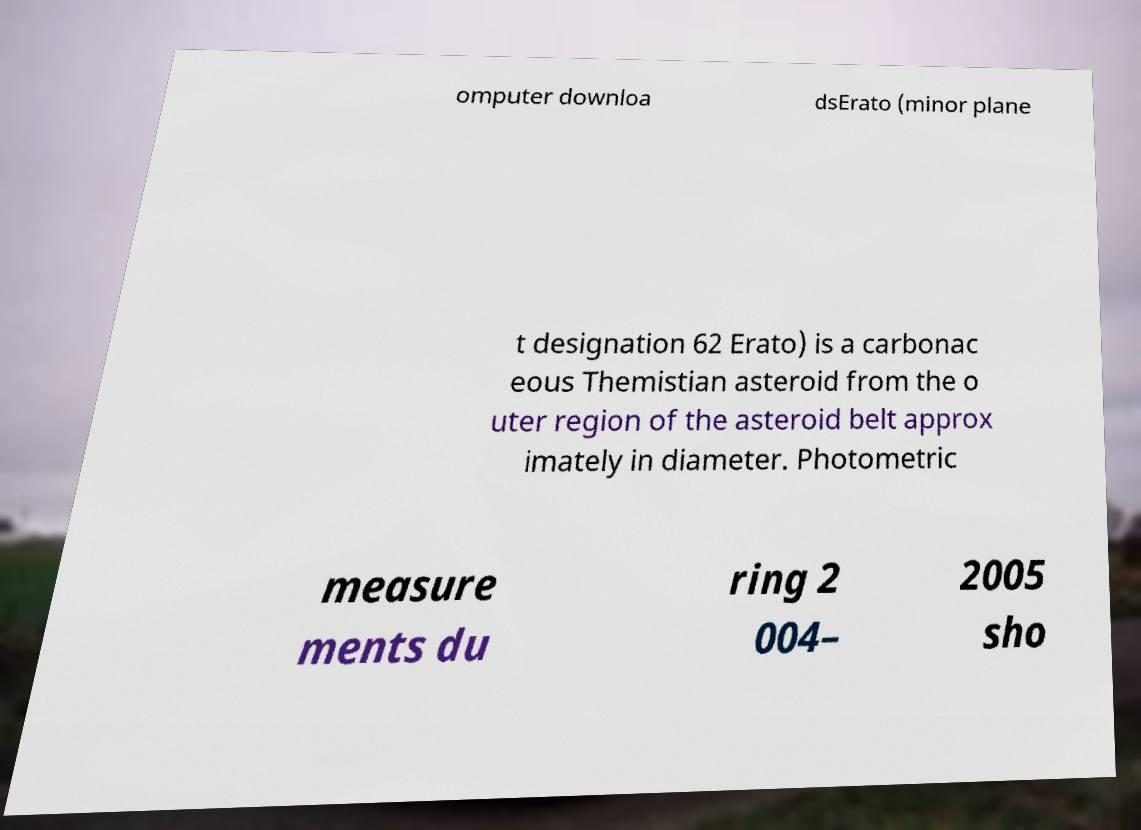Can you accurately transcribe the text from the provided image for me? omputer downloa dsErato (minor plane t designation 62 Erato) is a carbonac eous Themistian asteroid from the o uter region of the asteroid belt approx imately in diameter. Photometric measure ments du ring 2 004– 2005 sho 